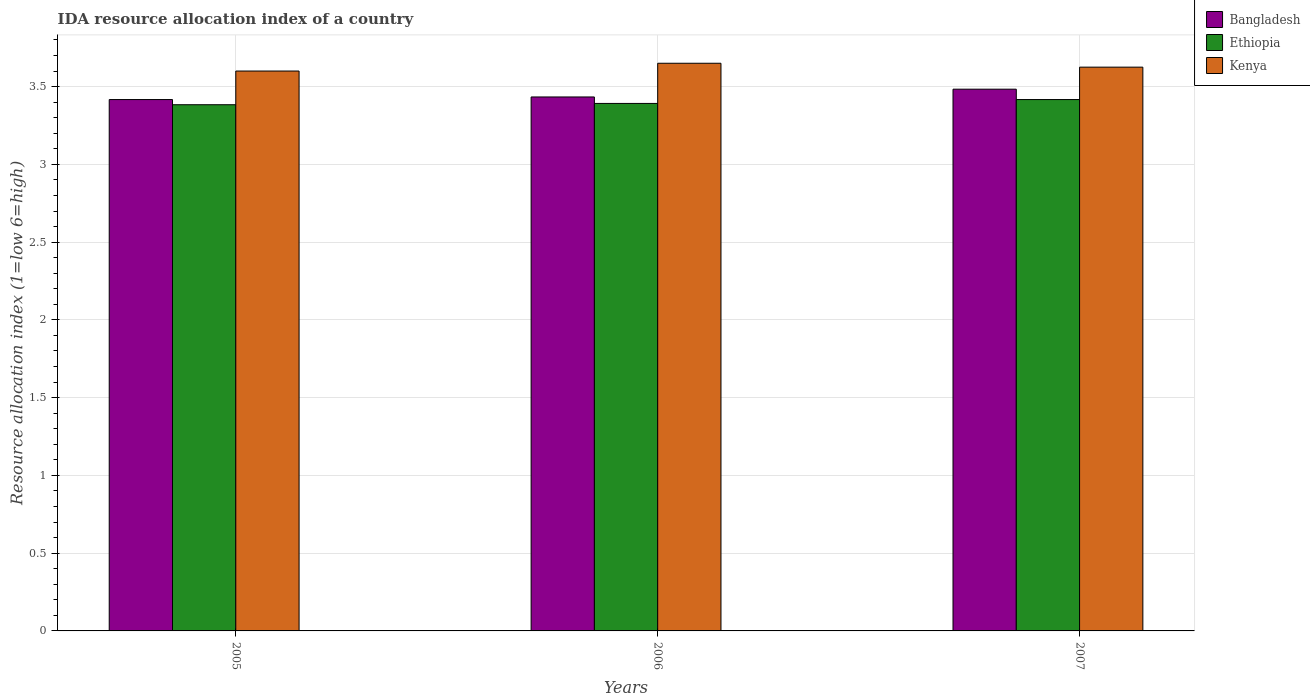How many groups of bars are there?
Ensure brevity in your answer.  3. Are the number of bars per tick equal to the number of legend labels?
Provide a short and direct response. Yes. How many bars are there on the 3rd tick from the right?
Give a very brief answer. 3. In how many cases, is the number of bars for a given year not equal to the number of legend labels?
Make the answer very short. 0. What is the IDA resource allocation index in Ethiopia in 2007?
Offer a terse response. 3.42. Across all years, what is the maximum IDA resource allocation index in Ethiopia?
Offer a very short reply. 3.42. Across all years, what is the minimum IDA resource allocation index in Ethiopia?
Keep it short and to the point. 3.38. In which year was the IDA resource allocation index in Ethiopia minimum?
Provide a succinct answer. 2005. What is the total IDA resource allocation index in Bangladesh in the graph?
Offer a terse response. 10.33. What is the difference between the IDA resource allocation index in Bangladesh in 2006 and that in 2007?
Your answer should be compact. -0.05. What is the difference between the IDA resource allocation index in Ethiopia in 2005 and the IDA resource allocation index in Bangladesh in 2006?
Your answer should be compact. -0.05. What is the average IDA resource allocation index in Ethiopia per year?
Offer a terse response. 3.4. In the year 2007, what is the difference between the IDA resource allocation index in Bangladesh and IDA resource allocation index in Ethiopia?
Provide a succinct answer. 0.07. In how many years, is the IDA resource allocation index in Kenya greater than 2.4?
Keep it short and to the point. 3. What is the ratio of the IDA resource allocation index in Bangladesh in 2006 to that in 2007?
Offer a terse response. 0.99. Is the IDA resource allocation index in Bangladesh in 2005 less than that in 2007?
Give a very brief answer. Yes. Is the difference between the IDA resource allocation index in Bangladesh in 2006 and 2007 greater than the difference between the IDA resource allocation index in Ethiopia in 2006 and 2007?
Your answer should be compact. No. What is the difference between the highest and the second highest IDA resource allocation index in Ethiopia?
Provide a succinct answer. 0.02. What is the difference between the highest and the lowest IDA resource allocation index in Kenya?
Keep it short and to the point. 0.05. In how many years, is the IDA resource allocation index in Ethiopia greater than the average IDA resource allocation index in Ethiopia taken over all years?
Your response must be concise. 1. What does the 2nd bar from the left in 2006 represents?
Offer a very short reply. Ethiopia. What does the 2nd bar from the right in 2007 represents?
Provide a succinct answer. Ethiopia. Are all the bars in the graph horizontal?
Give a very brief answer. No. What is the difference between two consecutive major ticks on the Y-axis?
Offer a terse response. 0.5. Are the values on the major ticks of Y-axis written in scientific E-notation?
Ensure brevity in your answer.  No. Does the graph contain any zero values?
Offer a terse response. No. Where does the legend appear in the graph?
Offer a terse response. Top right. How many legend labels are there?
Give a very brief answer. 3. How are the legend labels stacked?
Keep it short and to the point. Vertical. What is the title of the graph?
Your answer should be compact. IDA resource allocation index of a country. Does "Pakistan" appear as one of the legend labels in the graph?
Offer a very short reply. No. What is the label or title of the X-axis?
Keep it short and to the point. Years. What is the label or title of the Y-axis?
Provide a short and direct response. Resource allocation index (1=low 6=high). What is the Resource allocation index (1=low 6=high) in Bangladesh in 2005?
Offer a terse response. 3.42. What is the Resource allocation index (1=low 6=high) in Ethiopia in 2005?
Your answer should be very brief. 3.38. What is the Resource allocation index (1=low 6=high) in Kenya in 2005?
Provide a succinct answer. 3.6. What is the Resource allocation index (1=low 6=high) of Bangladesh in 2006?
Keep it short and to the point. 3.43. What is the Resource allocation index (1=low 6=high) of Ethiopia in 2006?
Offer a very short reply. 3.39. What is the Resource allocation index (1=low 6=high) in Kenya in 2006?
Make the answer very short. 3.65. What is the Resource allocation index (1=low 6=high) of Bangladesh in 2007?
Your answer should be very brief. 3.48. What is the Resource allocation index (1=low 6=high) of Ethiopia in 2007?
Offer a very short reply. 3.42. What is the Resource allocation index (1=low 6=high) of Kenya in 2007?
Keep it short and to the point. 3.62. Across all years, what is the maximum Resource allocation index (1=low 6=high) of Bangladesh?
Offer a very short reply. 3.48. Across all years, what is the maximum Resource allocation index (1=low 6=high) of Ethiopia?
Offer a very short reply. 3.42. Across all years, what is the maximum Resource allocation index (1=low 6=high) in Kenya?
Give a very brief answer. 3.65. Across all years, what is the minimum Resource allocation index (1=low 6=high) in Bangladesh?
Your response must be concise. 3.42. Across all years, what is the minimum Resource allocation index (1=low 6=high) in Ethiopia?
Your answer should be very brief. 3.38. What is the total Resource allocation index (1=low 6=high) in Bangladesh in the graph?
Ensure brevity in your answer.  10.33. What is the total Resource allocation index (1=low 6=high) of Ethiopia in the graph?
Your answer should be very brief. 10.19. What is the total Resource allocation index (1=low 6=high) in Kenya in the graph?
Provide a succinct answer. 10.88. What is the difference between the Resource allocation index (1=low 6=high) of Bangladesh in 2005 and that in 2006?
Give a very brief answer. -0.02. What is the difference between the Resource allocation index (1=low 6=high) in Ethiopia in 2005 and that in 2006?
Make the answer very short. -0.01. What is the difference between the Resource allocation index (1=low 6=high) in Bangladesh in 2005 and that in 2007?
Provide a short and direct response. -0.07. What is the difference between the Resource allocation index (1=low 6=high) of Ethiopia in 2005 and that in 2007?
Provide a short and direct response. -0.03. What is the difference between the Resource allocation index (1=low 6=high) of Kenya in 2005 and that in 2007?
Give a very brief answer. -0.03. What is the difference between the Resource allocation index (1=low 6=high) of Ethiopia in 2006 and that in 2007?
Make the answer very short. -0.03. What is the difference between the Resource allocation index (1=low 6=high) of Kenya in 2006 and that in 2007?
Make the answer very short. 0.03. What is the difference between the Resource allocation index (1=low 6=high) in Bangladesh in 2005 and the Resource allocation index (1=low 6=high) in Ethiopia in 2006?
Make the answer very short. 0.03. What is the difference between the Resource allocation index (1=low 6=high) of Bangladesh in 2005 and the Resource allocation index (1=low 6=high) of Kenya in 2006?
Make the answer very short. -0.23. What is the difference between the Resource allocation index (1=low 6=high) in Ethiopia in 2005 and the Resource allocation index (1=low 6=high) in Kenya in 2006?
Give a very brief answer. -0.27. What is the difference between the Resource allocation index (1=low 6=high) of Bangladesh in 2005 and the Resource allocation index (1=low 6=high) of Kenya in 2007?
Provide a short and direct response. -0.21. What is the difference between the Resource allocation index (1=low 6=high) of Ethiopia in 2005 and the Resource allocation index (1=low 6=high) of Kenya in 2007?
Give a very brief answer. -0.24. What is the difference between the Resource allocation index (1=low 6=high) of Bangladesh in 2006 and the Resource allocation index (1=low 6=high) of Ethiopia in 2007?
Make the answer very short. 0.02. What is the difference between the Resource allocation index (1=low 6=high) of Bangladesh in 2006 and the Resource allocation index (1=low 6=high) of Kenya in 2007?
Your answer should be compact. -0.19. What is the difference between the Resource allocation index (1=low 6=high) in Ethiopia in 2006 and the Resource allocation index (1=low 6=high) in Kenya in 2007?
Your answer should be very brief. -0.23. What is the average Resource allocation index (1=low 6=high) of Bangladesh per year?
Give a very brief answer. 3.44. What is the average Resource allocation index (1=low 6=high) in Ethiopia per year?
Your response must be concise. 3.4. What is the average Resource allocation index (1=low 6=high) in Kenya per year?
Make the answer very short. 3.62. In the year 2005, what is the difference between the Resource allocation index (1=low 6=high) in Bangladesh and Resource allocation index (1=low 6=high) in Kenya?
Make the answer very short. -0.18. In the year 2005, what is the difference between the Resource allocation index (1=low 6=high) in Ethiopia and Resource allocation index (1=low 6=high) in Kenya?
Provide a succinct answer. -0.22. In the year 2006, what is the difference between the Resource allocation index (1=low 6=high) of Bangladesh and Resource allocation index (1=low 6=high) of Ethiopia?
Your answer should be very brief. 0.04. In the year 2006, what is the difference between the Resource allocation index (1=low 6=high) in Bangladesh and Resource allocation index (1=low 6=high) in Kenya?
Your answer should be compact. -0.22. In the year 2006, what is the difference between the Resource allocation index (1=low 6=high) in Ethiopia and Resource allocation index (1=low 6=high) in Kenya?
Provide a succinct answer. -0.26. In the year 2007, what is the difference between the Resource allocation index (1=low 6=high) of Bangladesh and Resource allocation index (1=low 6=high) of Ethiopia?
Give a very brief answer. 0.07. In the year 2007, what is the difference between the Resource allocation index (1=low 6=high) in Bangladesh and Resource allocation index (1=low 6=high) in Kenya?
Your response must be concise. -0.14. In the year 2007, what is the difference between the Resource allocation index (1=low 6=high) of Ethiopia and Resource allocation index (1=low 6=high) of Kenya?
Your response must be concise. -0.21. What is the ratio of the Resource allocation index (1=low 6=high) of Bangladesh in 2005 to that in 2006?
Offer a terse response. 1. What is the ratio of the Resource allocation index (1=low 6=high) of Ethiopia in 2005 to that in 2006?
Ensure brevity in your answer.  1. What is the ratio of the Resource allocation index (1=low 6=high) of Kenya in 2005 to that in 2006?
Provide a succinct answer. 0.99. What is the ratio of the Resource allocation index (1=low 6=high) in Bangladesh in 2005 to that in 2007?
Give a very brief answer. 0.98. What is the ratio of the Resource allocation index (1=low 6=high) in Ethiopia in 2005 to that in 2007?
Ensure brevity in your answer.  0.99. What is the ratio of the Resource allocation index (1=low 6=high) in Kenya in 2005 to that in 2007?
Your response must be concise. 0.99. What is the ratio of the Resource allocation index (1=low 6=high) in Bangladesh in 2006 to that in 2007?
Provide a succinct answer. 0.99. What is the ratio of the Resource allocation index (1=low 6=high) of Ethiopia in 2006 to that in 2007?
Make the answer very short. 0.99. What is the ratio of the Resource allocation index (1=low 6=high) of Kenya in 2006 to that in 2007?
Provide a succinct answer. 1.01. What is the difference between the highest and the second highest Resource allocation index (1=low 6=high) in Bangladesh?
Provide a succinct answer. 0.05. What is the difference between the highest and the second highest Resource allocation index (1=low 6=high) of Ethiopia?
Offer a terse response. 0.03. What is the difference between the highest and the second highest Resource allocation index (1=low 6=high) of Kenya?
Keep it short and to the point. 0.03. What is the difference between the highest and the lowest Resource allocation index (1=low 6=high) of Bangladesh?
Give a very brief answer. 0.07. 